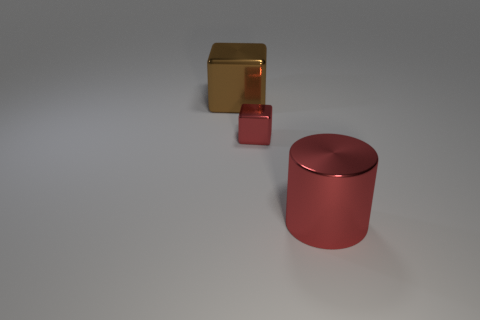Subtract all red cubes. How many cubes are left? 1 Subtract 0 green blocks. How many objects are left? 3 Subtract all cylinders. How many objects are left? 2 Subtract 2 cubes. How many cubes are left? 0 Subtract all blue cylinders. Subtract all purple balls. How many cylinders are left? 1 Subtract all purple balls. How many blue blocks are left? 0 Subtract all red metallic cubes. Subtract all big brown objects. How many objects are left? 1 Add 2 big red metal things. How many big red metal things are left? 3 Add 2 large shiny objects. How many large shiny objects exist? 4 Add 3 tiny metallic things. How many objects exist? 6 